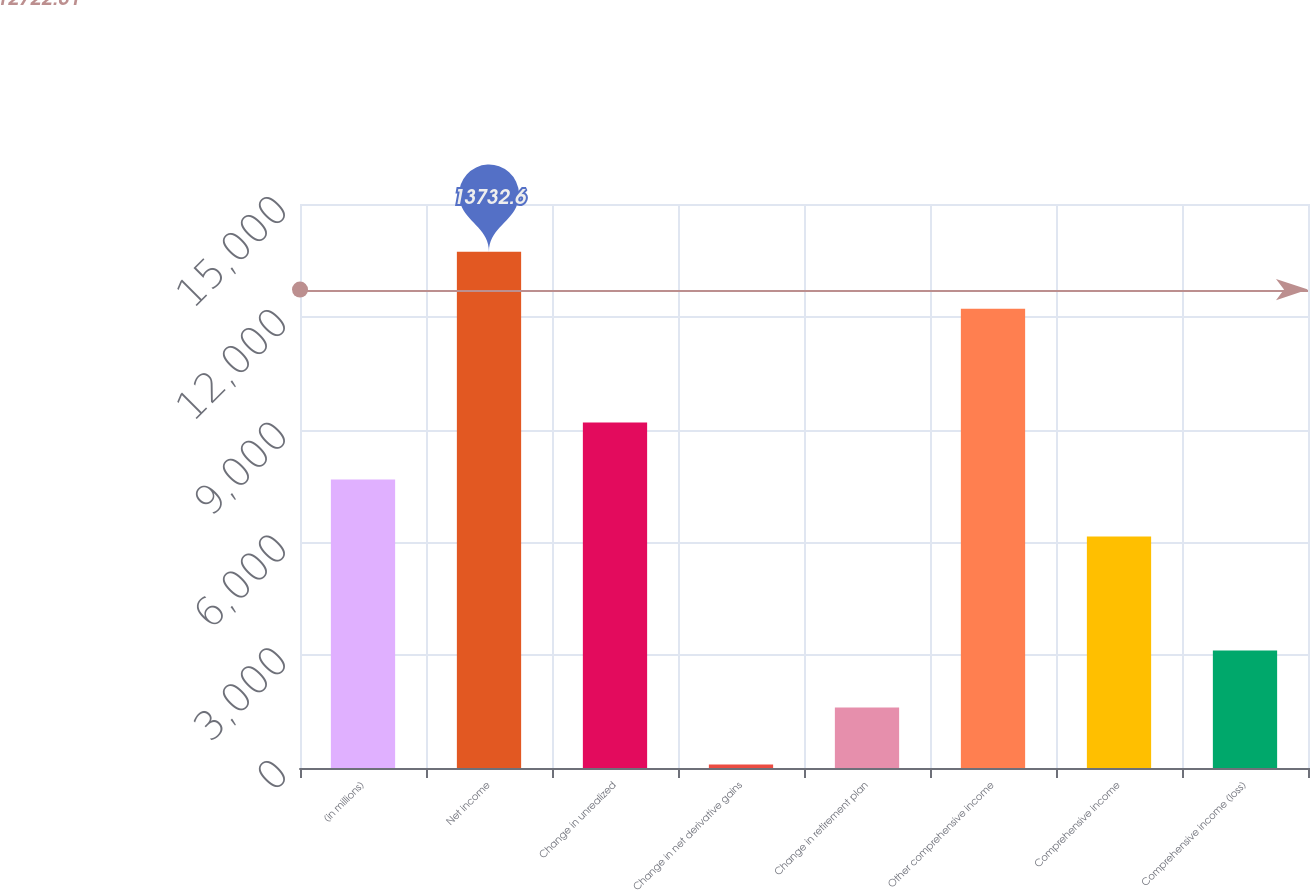Convert chart. <chart><loc_0><loc_0><loc_500><loc_500><bar_chart><fcel>(in millions)<fcel>Net income<fcel>Change in unrealized<fcel>Change in net derivative gains<fcel>Change in retirement plan<fcel>Other comprehensive income<fcel>Comprehensive income<fcel>Comprehensive income (loss)<nl><fcel>7671<fcel>13732.6<fcel>9186.4<fcel>94<fcel>1609.4<fcel>12217.2<fcel>6155.6<fcel>3124.8<nl></chart> 